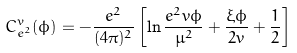Convert formula to latex. <formula><loc_0><loc_0><loc_500><loc_500>C ^ { v } _ { e ^ { 2 } } ( \phi ) = - \frac { e ^ { 2 } } { ( 4 \pi ) ^ { 2 } } \left [ \ln { \frac { e ^ { 2 } v \phi } { \mu ^ { 2 } } } + \frac { \xi \phi } { 2 v } + \frac { 1 } { 2 } \right ]</formula> 